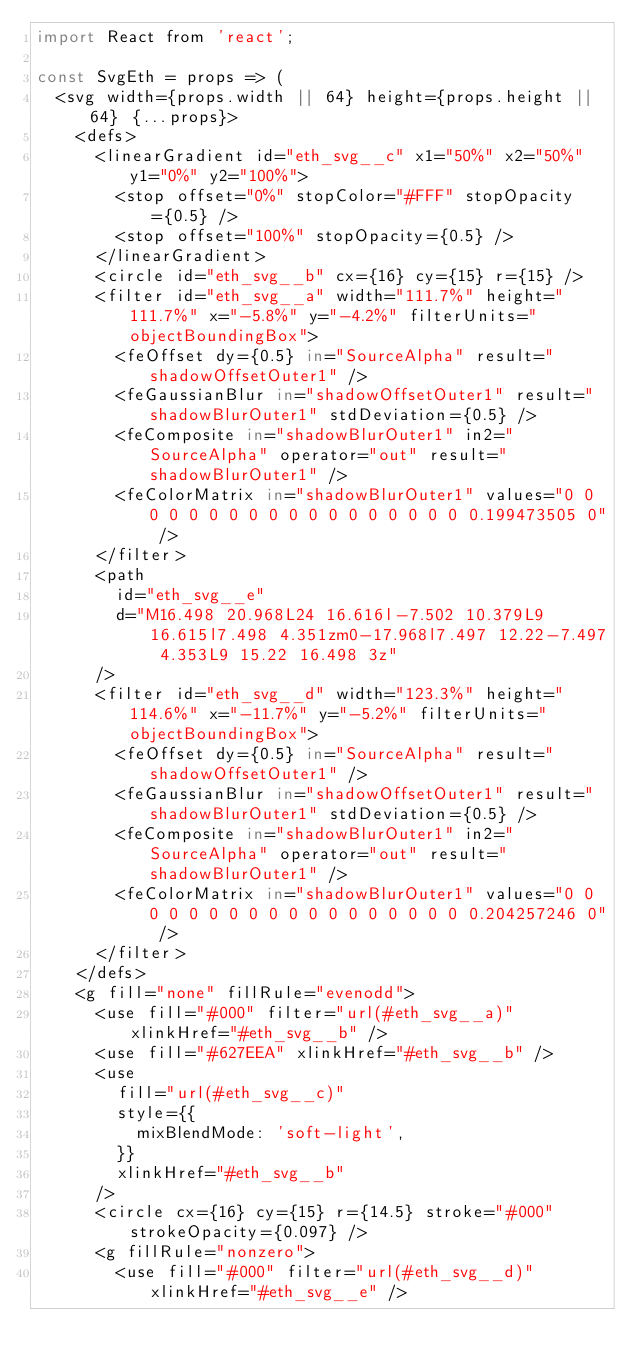Convert code to text. <code><loc_0><loc_0><loc_500><loc_500><_JavaScript_>import React from 'react';

const SvgEth = props => (
  <svg width={props.width || 64} height={props.height || 64} {...props}>
    <defs>
      <linearGradient id="eth_svg__c" x1="50%" x2="50%" y1="0%" y2="100%">
        <stop offset="0%" stopColor="#FFF" stopOpacity={0.5} />
        <stop offset="100%" stopOpacity={0.5} />
      </linearGradient>
      <circle id="eth_svg__b" cx={16} cy={15} r={15} />
      <filter id="eth_svg__a" width="111.7%" height="111.7%" x="-5.8%" y="-4.2%" filterUnits="objectBoundingBox">
        <feOffset dy={0.5} in="SourceAlpha" result="shadowOffsetOuter1" />
        <feGaussianBlur in="shadowOffsetOuter1" result="shadowBlurOuter1" stdDeviation={0.5} />
        <feComposite in="shadowBlurOuter1" in2="SourceAlpha" operator="out" result="shadowBlurOuter1" />
        <feColorMatrix in="shadowBlurOuter1" values="0 0 0 0 0 0 0 0 0 0 0 0 0 0 0 0 0 0 0.199473505 0" />
      </filter>
      <path
        id="eth_svg__e"
        d="M16.498 20.968L24 16.616l-7.502 10.379L9 16.615l7.498 4.351zm0-17.968l7.497 12.22-7.497 4.353L9 15.22 16.498 3z"
      />
      <filter id="eth_svg__d" width="123.3%" height="114.6%" x="-11.7%" y="-5.2%" filterUnits="objectBoundingBox">
        <feOffset dy={0.5} in="SourceAlpha" result="shadowOffsetOuter1" />
        <feGaussianBlur in="shadowOffsetOuter1" result="shadowBlurOuter1" stdDeviation={0.5} />
        <feComposite in="shadowBlurOuter1" in2="SourceAlpha" operator="out" result="shadowBlurOuter1" />
        <feColorMatrix in="shadowBlurOuter1" values="0 0 0 0 0 0 0 0 0 0 0 0 0 0 0 0 0 0 0.204257246 0" />
      </filter>
    </defs>
    <g fill="none" fillRule="evenodd">
      <use fill="#000" filter="url(#eth_svg__a)" xlinkHref="#eth_svg__b" />
      <use fill="#627EEA" xlinkHref="#eth_svg__b" />
      <use
        fill="url(#eth_svg__c)"
        style={{
          mixBlendMode: 'soft-light',
        }}
        xlinkHref="#eth_svg__b"
      />
      <circle cx={16} cy={15} r={14.5} stroke="#000" strokeOpacity={0.097} />
      <g fillRule="nonzero">
        <use fill="#000" filter="url(#eth_svg__d)" xlinkHref="#eth_svg__e" /></code> 